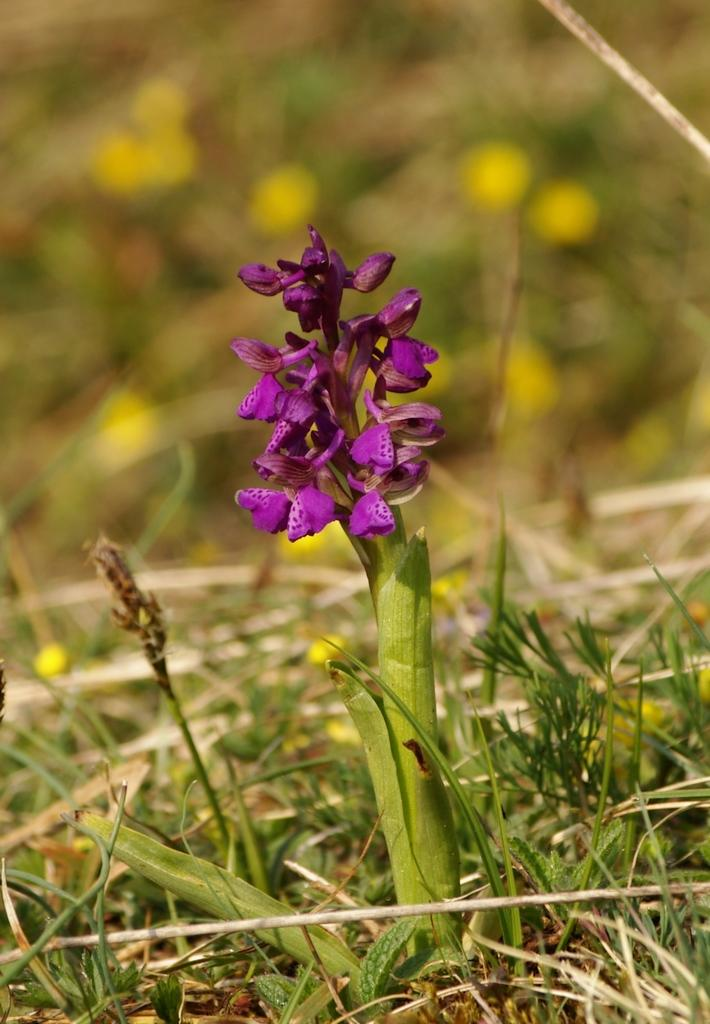What type of plant can be seen in the image? There is a flower plant in the image. Where is the flower plant located? The flower plant is on a surface. What type of stage is visible in the image? There is no stage present in the image; it features a flower plant on a surface. What force is being applied to the flower plant in the image? There is no force being applied to the flower plant in the image; it is simply sitting on a surface. 